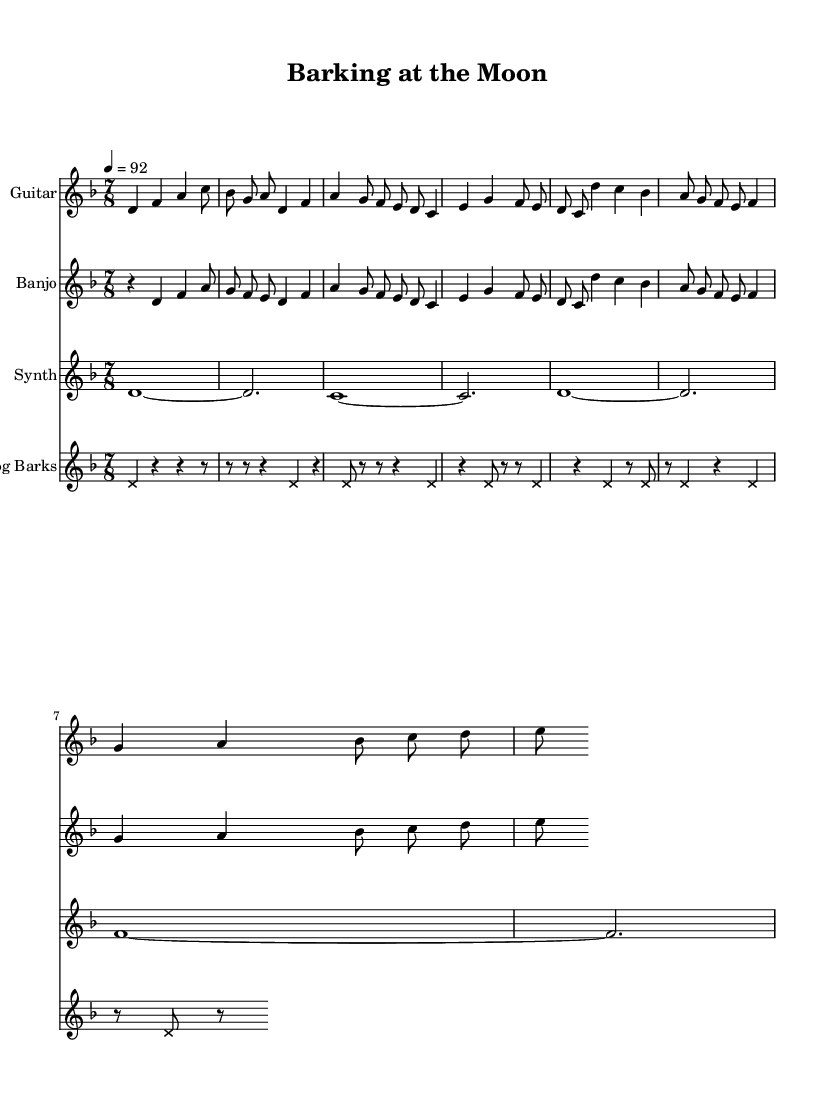What is the key signature of this music? The key signature is indicated at the beginning of the score, which shows two flats, signifying B flat and E flat. This corresponds to D minor.
Answer: D minor What is the time signature of this music? The time signature is located at the beginning of the score. It is indicated as 7/8, meaning there are seven eighth notes per measure.
Answer: 7/8 What is the tempo marking for this piece? The tempo indication is given at the beginning of the score as "4 = 92", which informs us that there are 92 beats per minute, with each beat being a quarter note.
Answer: 92 How many measures are there in the guitar part? By counting the distinct sections in the guitar music, we can determine there are 8 measures total across the intro, verse, and chorus.
Answer: 8 Which staff includes dog bark samples? The staffs are labeled with the instrument names, and the one labeled "Dog Barks" specifically includes the dog bark samples represented with x-shaped note heads.
Answer: Dog Barks What is the rhythmic pattern of the dog bark samples? The dog bark samples include rests and notes, with the rhythmic pattern showcasing alternating rests and pitches over four measures while being mostly consistent in length.
Answer: Alternating rests and pitches How does the synth part contribute to the overall texture? The synth part uses sustained notes that provide a backdrop for the rhythmic and melodic elements introduced by the guitar and banjo, creating a fusion of electronic sound with acoustic textures.
Answer: Sustained backdrop 